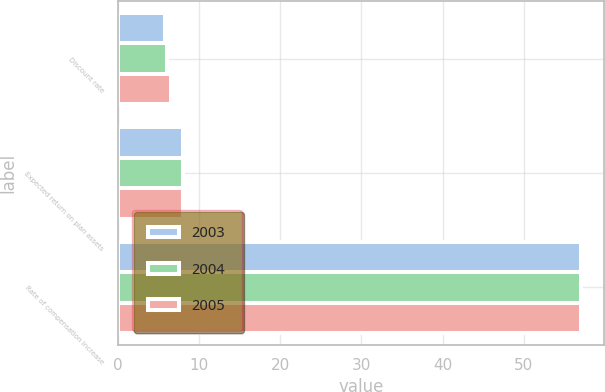Convert chart to OTSL. <chart><loc_0><loc_0><loc_500><loc_500><stacked_bar_chart><ecel><fcel>Discount rate<fcel>Expected return on plan assets<fcel>Rate of compensation increase<nl><fcel>2003<fcel>5.75<fcel>8<fcel>57<nl><fcel>2004<fcel>6<fcel>8<fcel>57<nl><fcel>2005<fcel>6.5<fcel>8<fcel>57<nl></chart> 